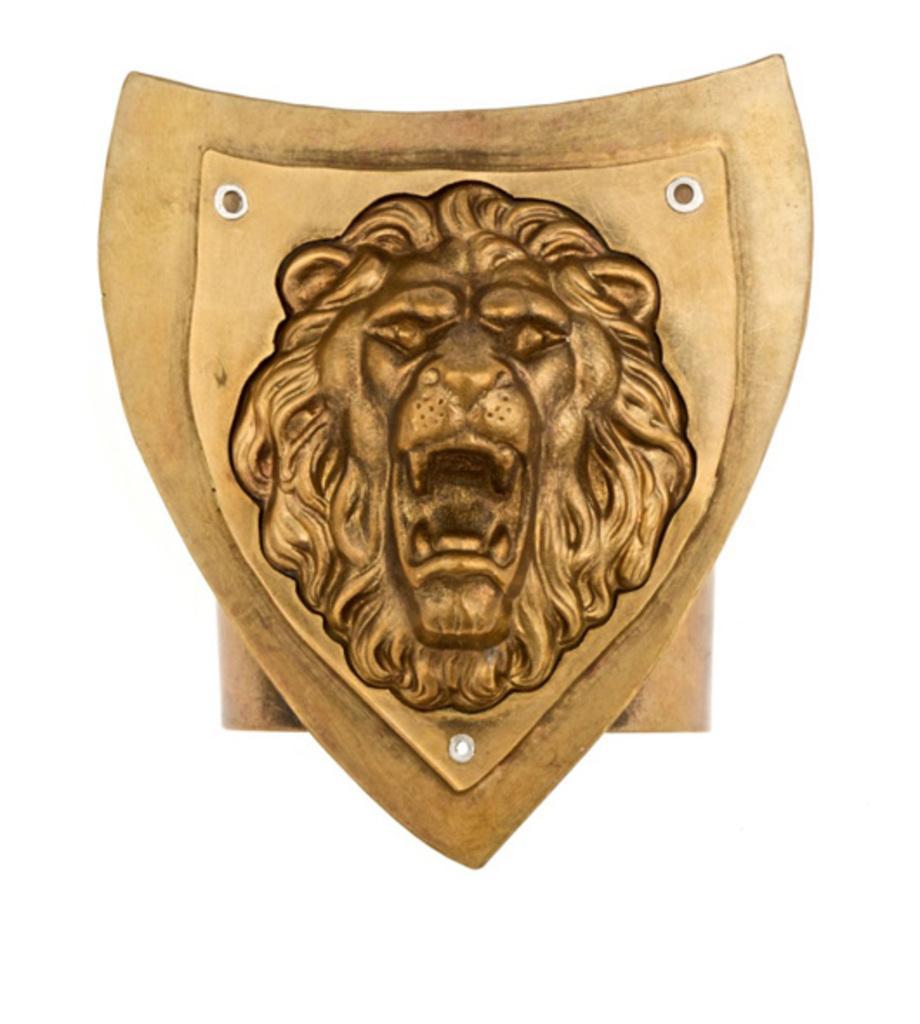Please provide a concise description of this image. This picture contains a lion shaped shield which is brown in color. 